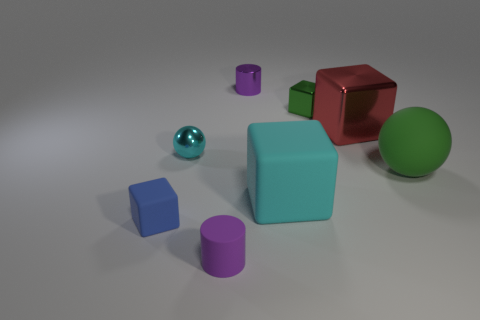Subtract all big matte cubes. How many cubes are left? 3 Subtract 1 cubes. How many cubes are left? 3 Subtract all cyan blocks. How many blocks are left? 3 Subtract all balls. How many objects are left? 6 Add 2 green objects. How many objects exist? 10 Subtract 1 blue blocks. How many objects are left? 7 Subtract all purple blocks. Subtract all brown spheres. How many blocks are left? 4 Subtract all green metallic cubes. Subtract all big blue blocks. How many objects are left? 7 Add 5 big green balls. How many big green balls are left? 6 Add 1 small gray spheres. How many small gray spheres exist? 1 